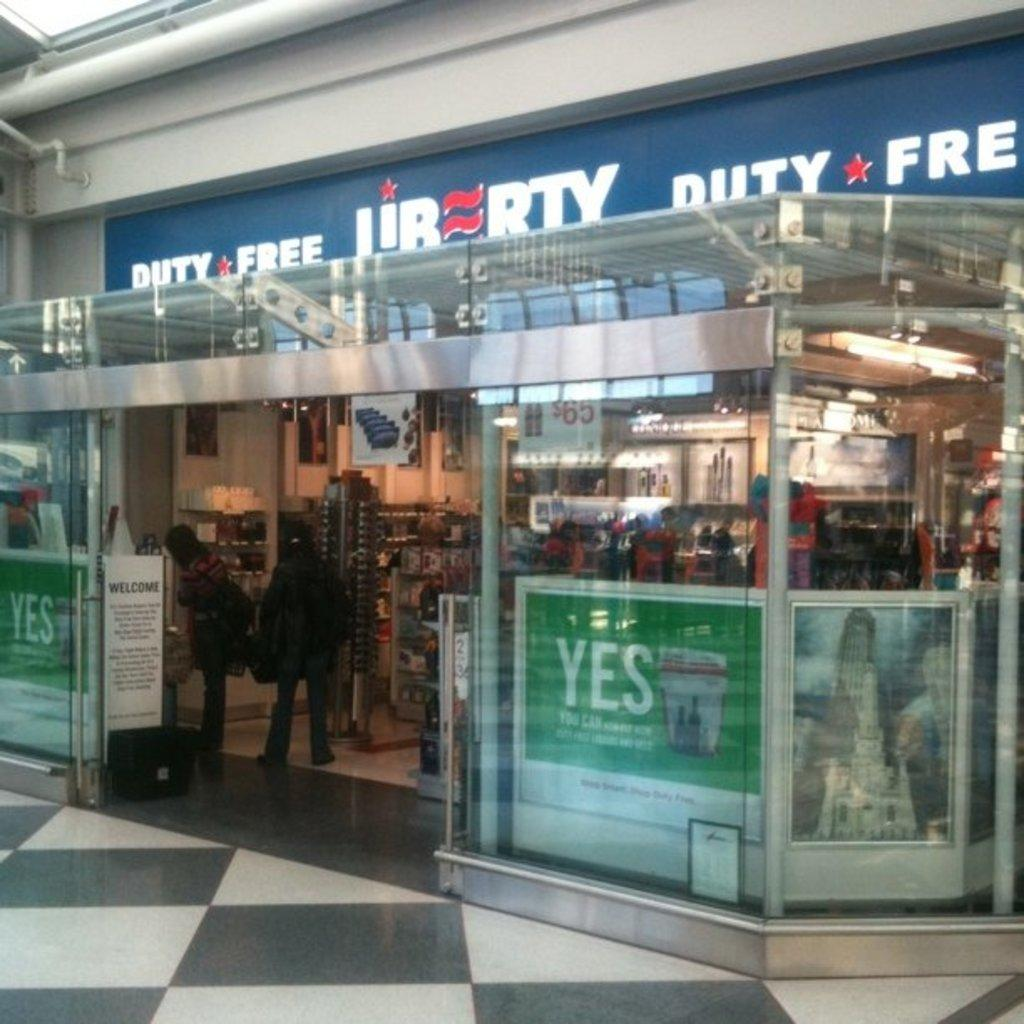<image>
Present a compact description of the photo's key features. A store, called Liberty, has the words duty free written next to its name. 